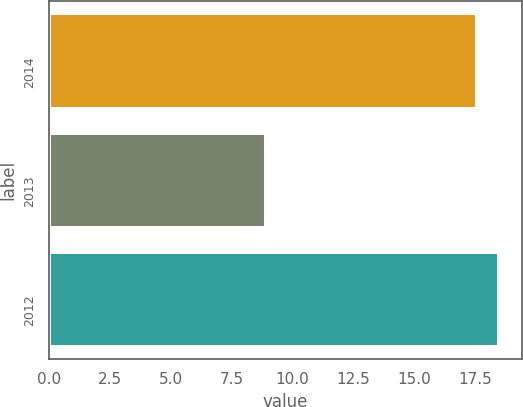<chart> <loc_0><loc_0><loc_500><loc_500><bar_chart><fcel>2014<fcel>2013<fcel>2012<nl><fcel>17.6<fcel>8.9<fcel>18.51<nl></chart> 